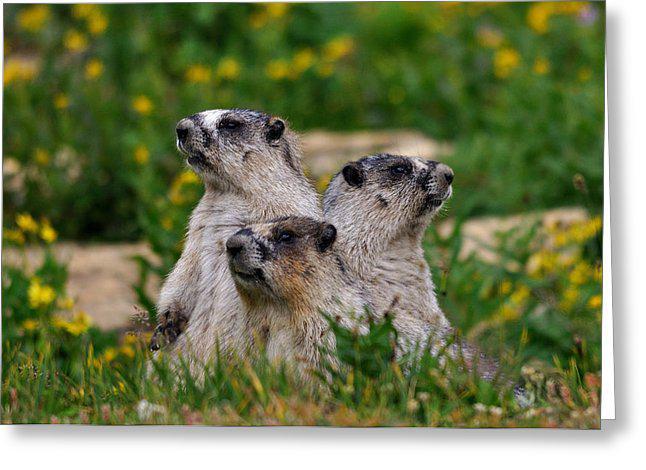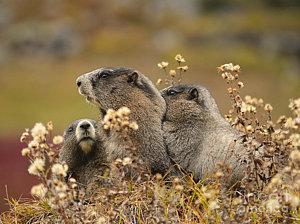The first image is the image on the left, the second image is the image on the right. For the images shown, is this caption "Each image contains at least three marmots in a close grouping." true? Answer yes or no. Yes. 